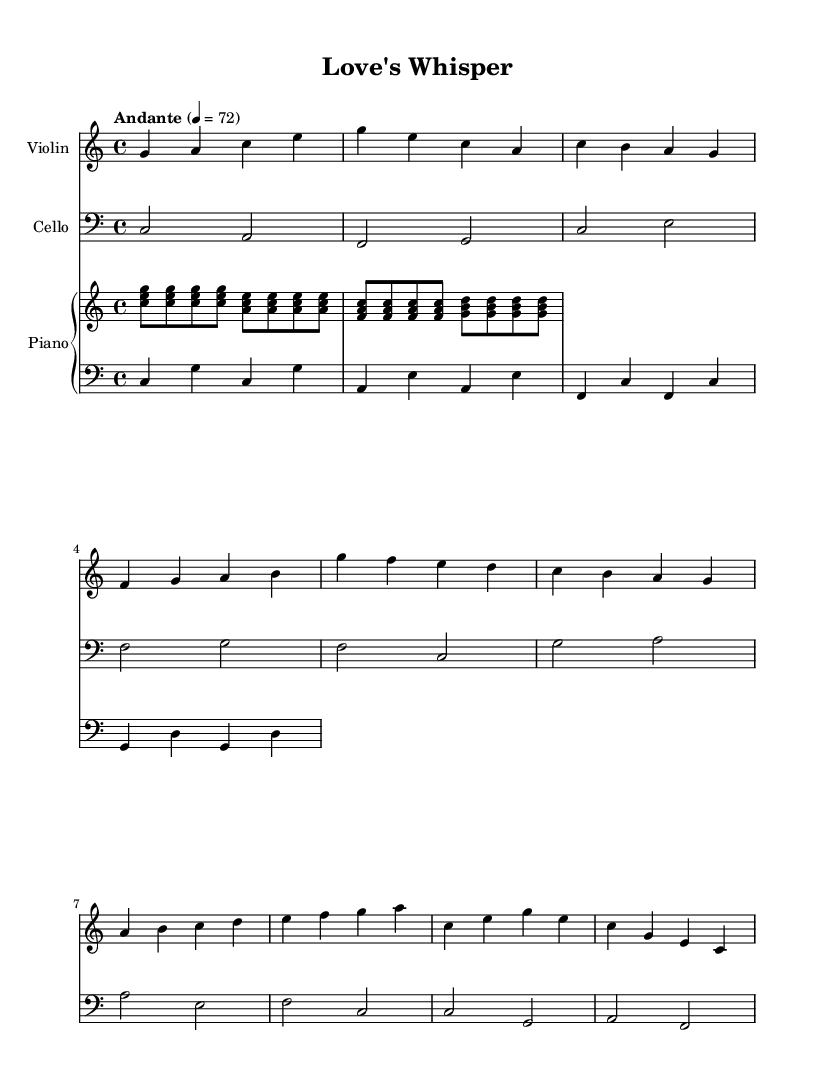What is the time signature of this music? The time signature is indicated at the beginning of the score where it shows "4/4", meaning there are four beats in each measure and the quarter note gets one beat.
Answer: 4/4 What is the tempo marking for this piece? The tempo marking is found after the time signature and states "Andante" with a metronome marking of 4 = 72, indicating a moderate pace.
Answer: Andante What key is this composition in? The key signature is indicated at the start of the piece with "c major", meaning it has no sharps or flats.
Answer: C major How many measures are there in the first section of the piece? The first section, which includes the intro, contains 4 measures; each subdivision of the phrases can be counted to confirm this.
Answer: 4 measures Which instrument has the highest pitch in this score? In the score, the violin part is notated in a higher octave compared to the cello and piano parts which are lower, making it the highest pitch here.
Answer: Violin What is the role of the cello in this composition? The cello primarily supports the harmonic structure and often plays a bass line, complementing the melodies in the violin and piano.
Answer: Supportive Which section of the piece has the notes mostly rising? The bridge section primarily features ascending notes via the violin part, moving generally from lower pitches to higher pitches, indicating a rise in tension.
Answer: Bridge 